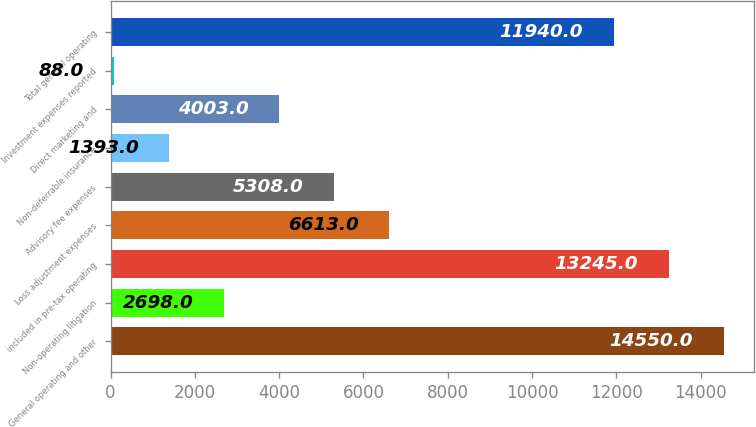<chart> <loc_0><loc_0><loc_500><loc_500><bar_chart><fcel>General operating and other<fcel>Non-operating litigation<fcel>included in pre-tax operating<fcel>Loss adjustment expenses<fcel>Advisory fee expenses<fcel>Non-deferrable insurance<fcel>Direct marketing and<fcel>Investment expenses reported<fcel>Total general operating<nl><fcel>14550<fcel>2698<fcel>13245<fcel>6613<fcel>5308<fcel>1393<fcel>4003<fcel>88<fcel>11940<nl></chart> 